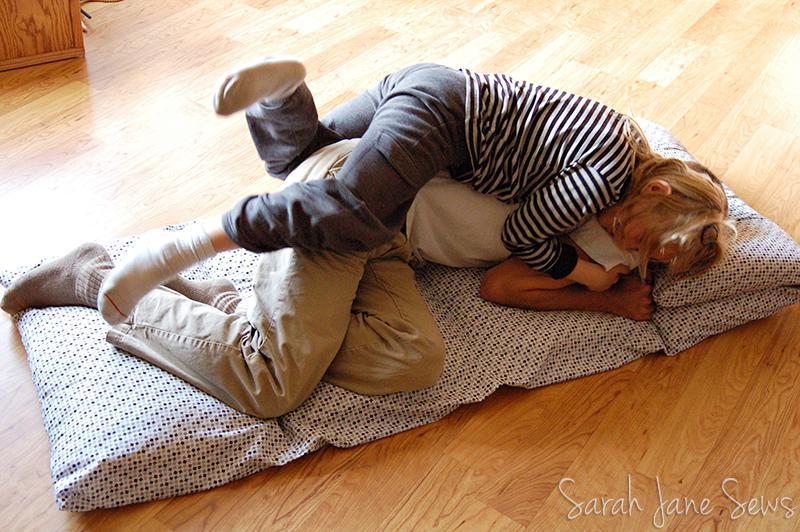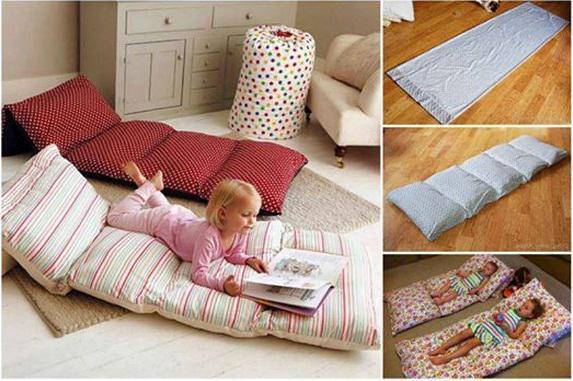The first image is the image on the left, the second image is the image on the right. Analyze the images presented: Is the assertion "The right image contains two children." valid? Answer yes or no. No. The first image is the image on the left, the second image is the image on the right. Assess this claim about the two images: "The left image includes two people on some type of cushioned surface, and the right image features at least one little girl lying on her stomach on a mat consisting of several pillow sections.". Correct or not? Answer yes or no. Yes. 